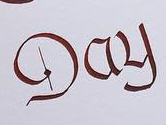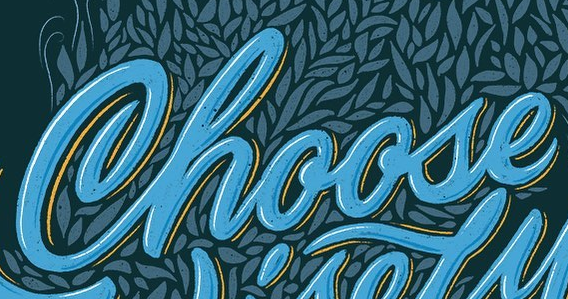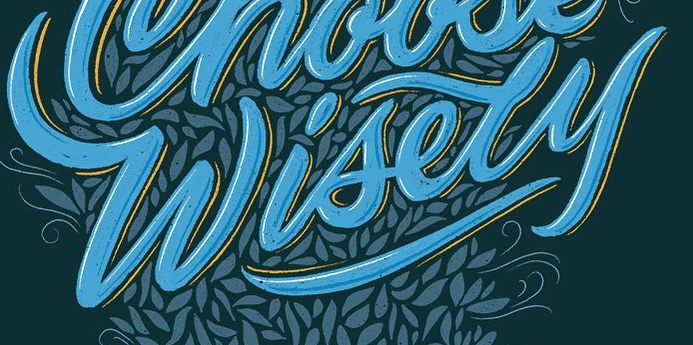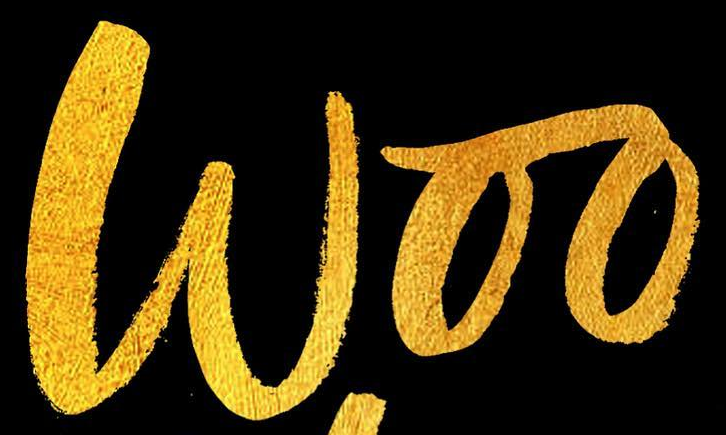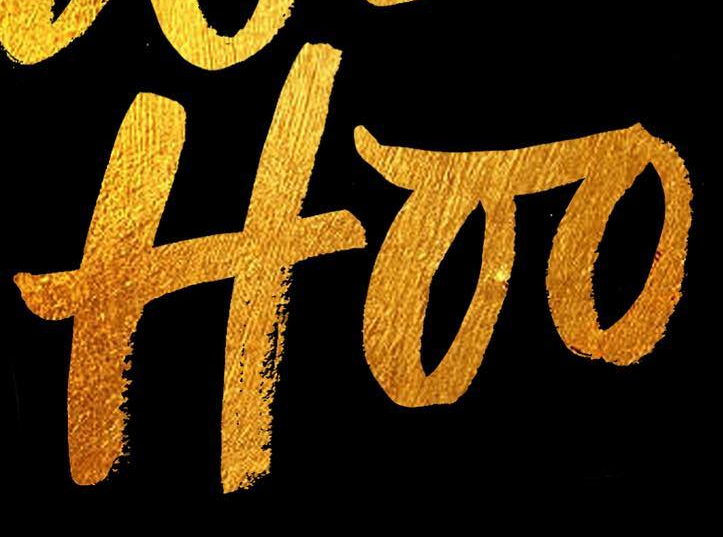Read the text content from these images in order, separated by a semicolon. Day; Choose; Wisely; Woo; Hoo 